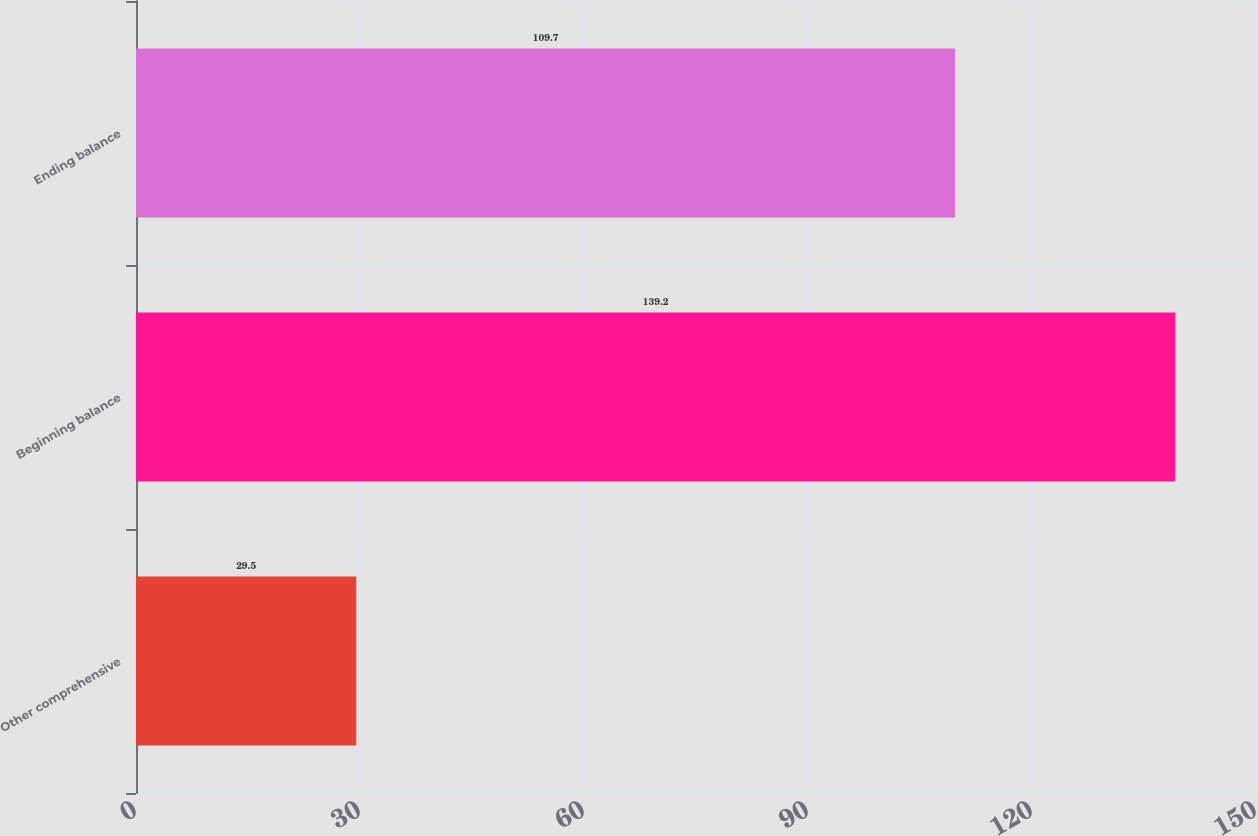Convert chart. <chart><loc_0><loc_0><loc_500><loc_500><bar_chart><fcel>Other comprehensive<fcel>Beginning balance<fcel>Ending balance<nl><fcel>29.5<fcel>139.2<fcel>109.7<nl></chart> 